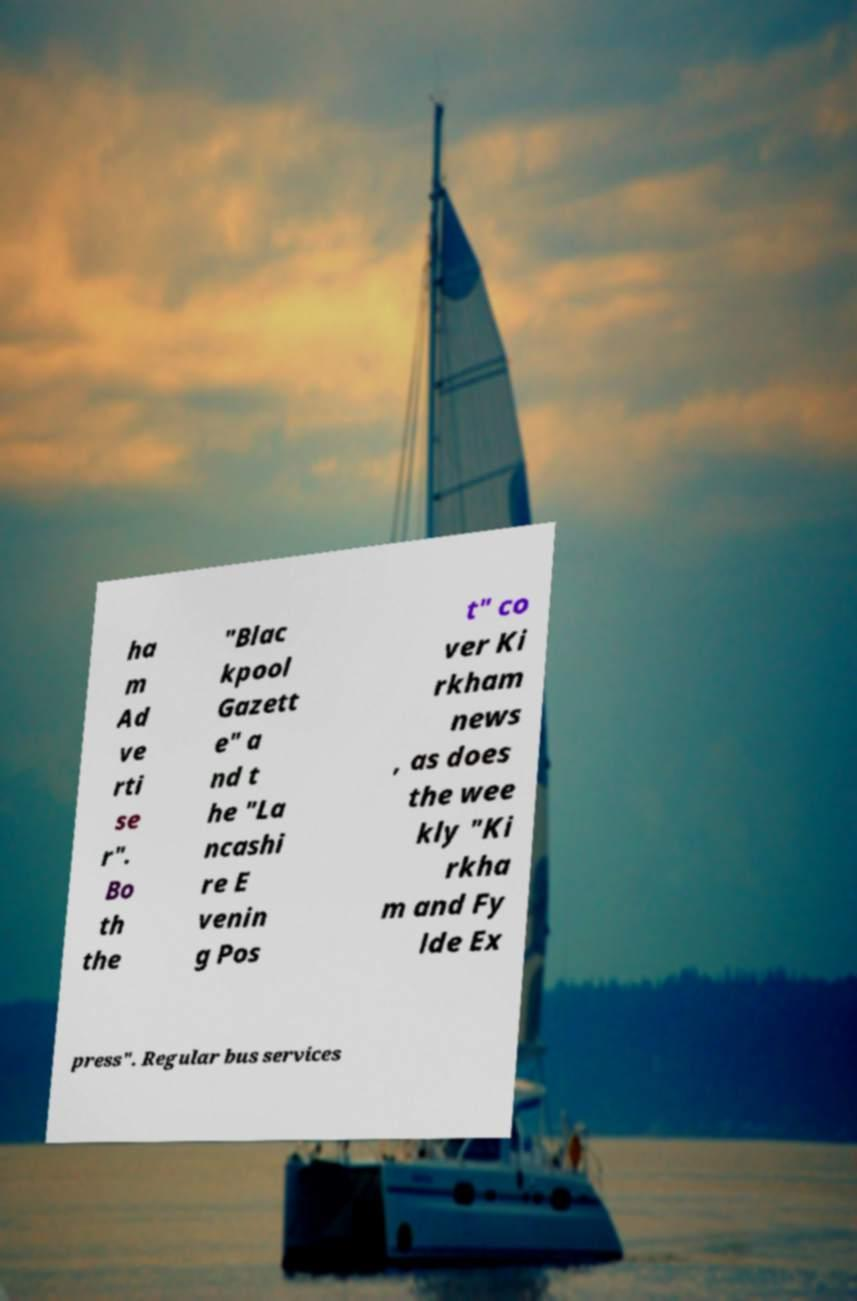Could you assist in decoding the text presented in this image and type it out clearly? ha m Ad ve rti se r". Bo th the "Blac kpool Gazett e" a nd t he "La ncashi re E venin g Pos t" co ver Ki rkham news , as does the wee kly "Ki rkha m and Fy lde Ex press". Regular bus services 